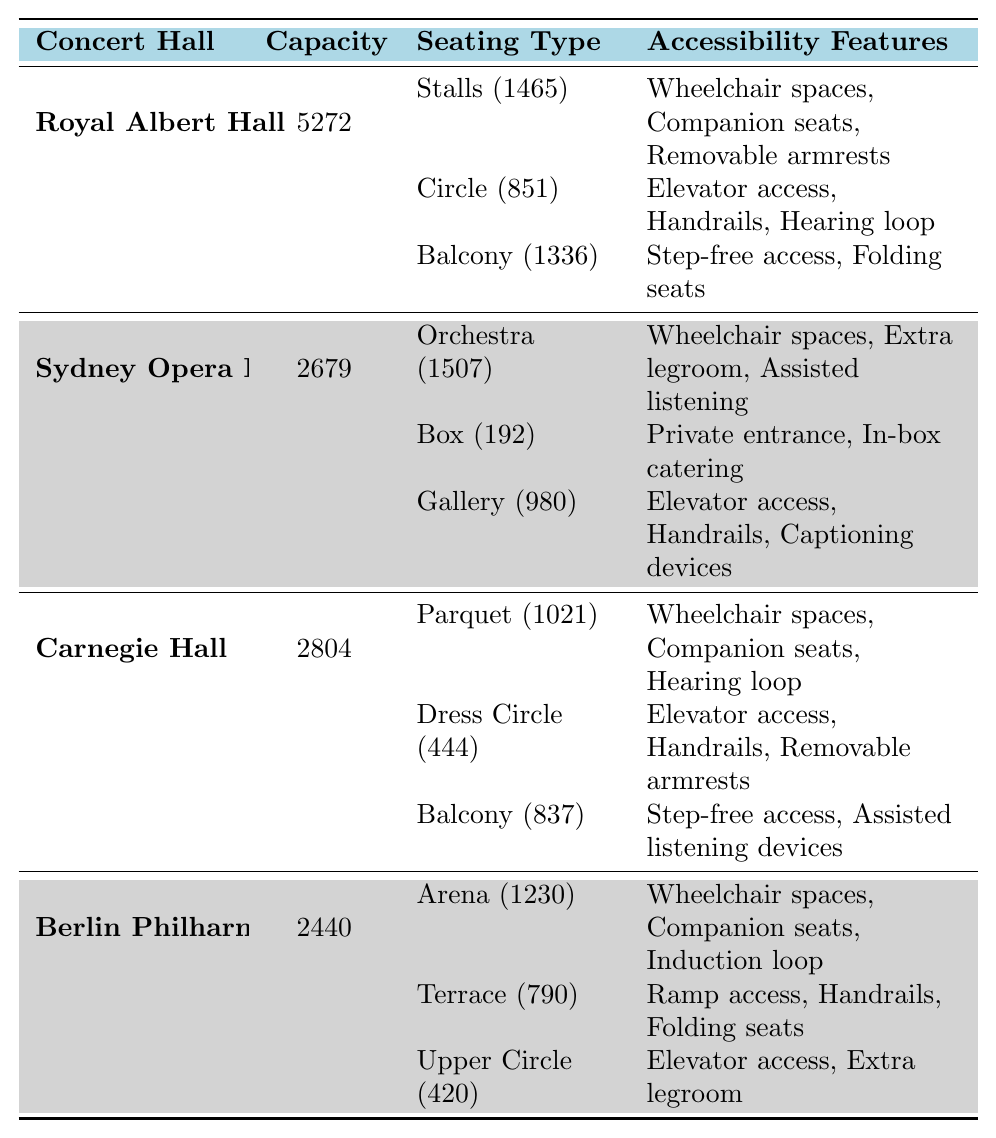What is the total seating capacity of the Royal Albert Hall? To find the total seating capacity of the Royal Albert Hall, we refer to the table where it is listed as 5272.
Answer: 5272 How many unique seating types does Sydney Opera House offer? The table shows that Sydney Opera House has three unique seating types: Orchestra, Box, and Gallery.
Answer: 3 What are the accessibility features of the Circle seating in Royal Albert Hall? By checking the table under Royal Albert Hall's Circle seating section, we see the accessibility features listed are Elevator access, Handrails, and Hearing loop.
Answer: Elevator access, Handrails, Hearing loop Which concert hall has the highest total seating capacity? Comparing the seating capacities from the table: Royal Albert Hall (5272), Sydney Opera House (2679), Carnegie Hall (2804), and Berlin Philharmonie (2440), Royal Albert Hall has the highest capacity at 5272.
Answer: Royal Albert Hall Does Carnegie Hall have wheelchair spaces in its seating arrangements? Looking at the seating arrangements in the table, we see that both the Parquet and Balcony seating types in Carnegie Hall feature wheelchair spaces, validating that it does.
Answer: Yes What is the total seating capacity of all seating types in Berlin Philharmonie? Adding the capacities from the seating types: Arena (1230), Terrace (790), Upper Circle (420) gives us 1230 + 790 + 420 = 2440, which matches the total listed capacity for Berlin Philharmonie, confirming all seating types sum correctly.
Answer: 2440 Which concert hall features a private entrance as an accessibility feature? Referring to the table, Sydney Opera House has a Box seating arrangement that includes a private entrance among its features.
Answer: Sydney Opera House Are all seating types in Sydney Opera House equipped with elevator access? Examining the table for Sydney Opera House: only the Gallery seating has elevator access. The Orchestra seating does not specify elevator access, while the Box seating has a private entrance instead. Thus, not all types have elevator access.
Answer: No What common accessibility feature do both the Stalls in Royal Albert Hall and the Parquet in Carnegie Hall share? By checking the accessibility features in the table, we see both the Stalls in Royal Albert Hall and the Parquet in Carnegie Hall offer wheelchair spaces.
Answer: Wheelchair spaces If the Orchestra seating in Sydney Opera House has 1507 seats and the Box seating has 192, what's the total capacity for just those two seating types? To find the total, we simply add the capacity of the Orchestra (1507) and the Box (192): 1507 + 192 = 1699.
Answer: 1699 